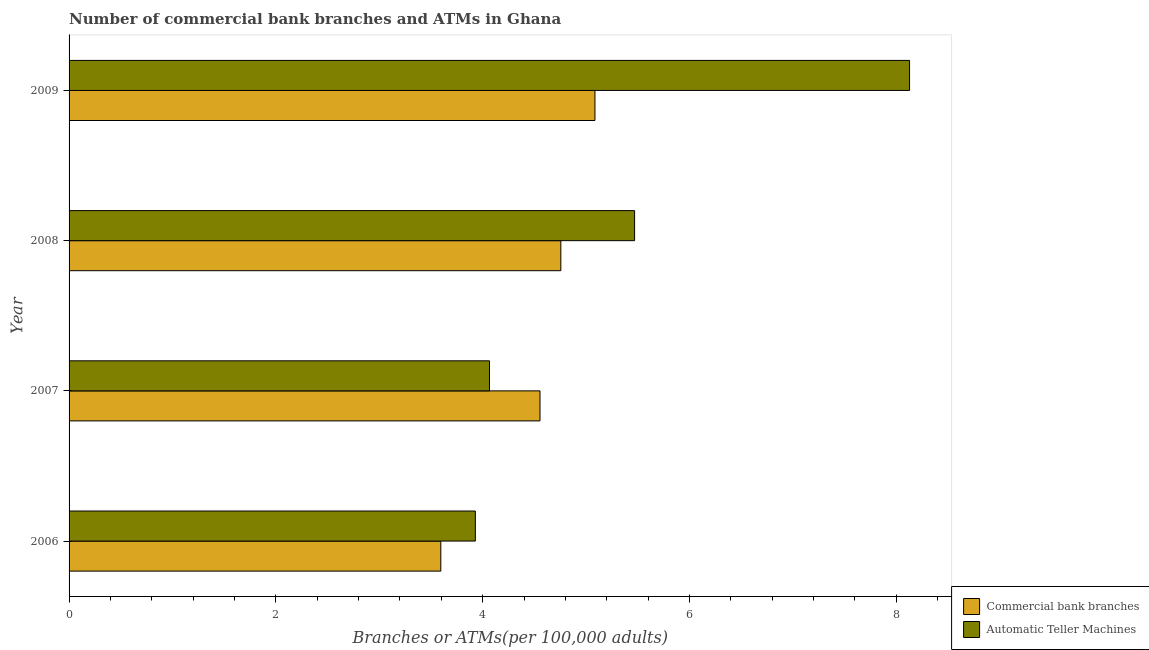How many different coloured bars are there?
Your answer should be very brief. 2. How many groups of bars are there?
Offer a very short reply. 4. Are the number of bars per tick equal to the number of legend labels?
Your answer should be very brief. Yes. Are the number of bars on each tick of the Y-axis equal?
Keep it short and to the point. Yes. What is the label of the 1st group of bars from the top?
Make the answer very short. 2009. What is the number of commercal bank branches in 2006?
Give a very brief answer. 3.6. Across all years, what is the maximum number of commercal bank branches?
Ensure brevity in your answer.  5.09. Across all years, what is the minimum number of atms?
Provide a succinct answer. 3.93. In which year was the number of atms minimum?
Make the answer very short. 2006. What is the total number of atms in the graph?
Provide a short and direct response. 21.59. What is the difference between the number of commercal bank branches in 2006 and that in 2008?
Provide a short and direct response. -1.16. What is the difference between the number of atms in 2006 and the number of commercal bank branches in 2008?
Your response must be concise. -0.83. What is the average number of commercal bank branches per year?
Keep it short and to the point. 4.5. In the year 2007, what is the difference between the number of commercal bank branches and number of atms?
Make the answer very short. 0.49. What is the ratio of the number of atms in 2006 to that in 2009?
Make the answer very short. 0.48. Is the number of atms in 2007 less than that in 2009?
Give a very brief answer. Yes. What is the difference between the highest and the second highest number of commercal bank branches?
Keep it short and to the point. 0.33. Is the sum of the number of commercal bank branches in 2007 and 2009 greater than the maximum number of atms across all years?
Keep it short and to the point. Yes. What does the 2nd bar from the top in 2008 represents?
Your answer should be compact. Commercial bank branches. What does the 2nd bar from the bottom in 2006 represents?
Your response must be concise. Automatic Teller Machines. How many years are there in the graph?
Provide a short and direct response. 4. Are the values on the major ticks of X-axis written in scientific E-notation?
Your response must be concise. No. Does the graph contain grids?
Keep it short and to the point. No. What is the title of the graph?
Give a very brief answer. Number of commercial bank branches and ATMs in Ghana. Does "Number of departures" appear as one of the legend labels in the graph?
Provide a short and direct response. No. What is the label or title of the X-axis?
Offer a very short reply. Branches or ATMs(per 100,0 adults). What is the label or title of the Y-axis?
Make the answer very short. Year. What is the Branches or ATMs(per 100,000 adults) of Commercial bank branches in 2006?
Your answer should be compact. 3.6. What is the Branches or ATMs(per 100,000 adults) of Automatic Teller Machines in 2006?
Keep it short and to the point. 3.93. What is the Branches or ATMs(per 100,000 adults) of Commercial bank branches in 2007?
Provide a succinct answer. 4.55. What is the Branches or ATMs(per 100,000 adults) of Automatic Teller Machines in 2007?
Ensure brevity in your answer.  4.07. What is the Branches or ATMs(per 100,000 adults) of Commercial bank branches in 2008?
Offer a terse response. 4.76. What is the Branches or ATMs(per 100,000 adults) in Automatic Teller Machines in 2008?
Give a very brief answer. 5.47. What is the Branches or ATMs(per 100,000 adults) of Commercial bank branches in 2009?
Provide a succinct answer. 5.09. What is the Branches or ATMs(per 100,000 adults) in Automatic Teller Machines in 2009?
Your answer should be very brief. 8.13. Across all years, what is the maximum Branches or ATMs(per 100,000 adults) in Commercial bank branches?
Make the answer very short. 5.09. Across all years, what is the maximum Branches or ATMs(per 100,000 adults) in Automatic Teller Machines?
Ensure brevity in your answer.  8.13. Across all years, what is the minimum Branches or ATMs(per 100,000 adults) of Commercial bank branches?
Your response must be concise. 3.6. Across all years, what is the minimum Branches or ATMs(per 100,000 adults) in Automatic Teller Machines?
Provide a short and direct response. 3.93. What is the total Branches or ATMs(per 100,000 adults) of Commercial bank branches in the graph?
Keep it short and to the point. 17.99. What is the total Branches or ATMs(per 100,000 adults) in Automatic Teller Machines in the graph?
Make the answer very short. 21.59. What is the difference between the Branches or ATMs(per 100,000 adults) of Commercial bank branches in 2006 and that in 2007?
Provide a short and direct response. -0.96. What is the difference between the Branches or ATMs(per 100,000 adults) of Automatic Teller Machines in 2006 and that in 2007?
Keep it short and to the point. -0.14. What is the difference between the Branches or ATMs(per 100,000 adults) of Commercial bank branches in 2006 and that in 2008?
Keep it short and to the point. -1.16. What is the difference between the Branches or ATMs(per 100,000 adults) in Automatic Teller Machines in 2006 and that in 2008?
Offer a terse response. -1.54. What is the difference between the Branches or ATMs(per 100,000 adults) of Commercial bank branches in 2006 and that in 2009?
Provide a succinct answer. -1.49. What is the difference between the Branches or ATMs(per 100,000 adults) in Automatic Teller Machines in 2006 and that in 2009?
Provide a short and direct response. -4.2. What is the difference between the Branches or ATMs(per 100,000 adults) of Commercial bank branches in 2007 and that in 2008?
Offer a terse response. -0.2. What is the difference between the Branches or ATMs(per 100,000 adults) of Automatic Teller Machines in 2007 and that in 2008?
Make the answer very short. -1.4. What is the difference between the Branches or ATMs(per 100,000 adults) of Commercial bank branches in 2007 and that in 2009?
Provide a succinct answer. -0.53. What is the difference between the Branches or ATMs(per 100,000 adults) of Automatic Teller Machines in 2007 and that in 2009?
Give a very brief answer. -4.06. What is the difference between the Branches or ATMs(per 100,000 adults) in Commercial bank branches in 2008 and that in 2009?
Offer a terse response. -0.33. What is the difference between the Branches or ATMs(per 100,000 adults) of Automatic Teller Machines in 2008 and that in 2009?
Keep it short and to the point. -2.66. What is the difference between the Branches or ATMs(per 100,000 adults) of Commercial bank branches in 2006 and the Branches or ATMs(per 100,000 adults) of Automatic Teller Machines in 2007?
Offer a terse response. -0.47. What is the difference between the Branches or ATMs(per 100,000 adults) of Commercial bank branches in 2006 and the Branches or ATMs(per 100,000 adults) of Automatic Teller Machines in 2008?
Your response must be concise. -1.87. What is the difference between the Branches or ATMs(per 100,000 adults) of Commercial bank branches in 2006 and the Branches or ATMs(per 100,000 adults) of Automatic Teller Machines in 2009?
Make the answer very short. -4.53. What is the difference between the Branches or ATMs(per 100,000 adults) in Commercial bank branches in 2007 and the Branches or ATMs(per 100,000 adults) in Automatic Teller Machines in 2008?
Make the answer very short. -0.91. What is the difference between the Branches or ATMs(per 100,000 adults) in Commercial bank branches in 2007 and the Branches or ATMs(per 100,000 adults) in Automatic Teller Machines in 2009?
Keep it short and to the point. -3.57. What is the difference between the Branches or ATMs(per 100,000 adults) of Commercial bank branches in 2008 and the Branches or ATMs(per 100,000 adults) of Automatic Teller Machines in 2009?
Your response must be concise. -3.37. What is the average Branches or ATMs(per 100,000 adults) of Commercial bank branches per year?
Offer a very short reply. 4.5. What is the average Branches or ATMs(per 100,000 adults) of Automatic Teller Machines per year?
Offer a very short reply. 5.4. In the year 2006, what is the difference between the Branches or ATMs(per 100,000 adults) of Commercial bank branches and Branches or ATMs(per 100,000 adults) of Automatic Teller Machines?
Ensure brevity in your answer.  -0.33. In the year 2007, what is the difference between the Branches or ATMs(per 100,000 adults) of Commercial bank branches and Branches or ATMs(per 100,000 adults) of Automatic Teller Machines?
Your answer should be compact. 0.49. In the year 2008, what is the difference between the Branches or ATMs(per 100,000 adults) of Commercial bank branches and Branches or ATMs(per 100,000 adults) of Automatic Teller Machines?
Provide a short and direct response. -0.71. In the year 2009, what is the difference between the Branches or ATMs(per 100,000 adults) in Commercial bank branches and Branches or ATMs(per 100,000 adults) in Automatic Teller Machines?
Your answer should be compact. -3.04. What is the ratio of the Branches or ATMs(per 100,000 adults) of Commercial bank branches in 2006 to that in 2007?
Make the answer very short. 0.79. What is the ratio of the Branches or ATMs(per 100,000 adults) of Automatic Teller Machines in 2006 to that in 2007?
Offer a terse response. 0.97. What is the ratio of the Branches or ATMs(per 100,000 adults) in Commercial bank branches in 2006 to that in 2008?
Give a very brief answer. 0.76. What is the ratio of the Branches or ATMs(per 100,000 adults) of Automatic Teller Machines in 2006 to that in 2008?
Keep it short and to the point. 0.72. What is the ratio of the Branches or ATMs(per 100,000 adults) in Commercial bank branches in 2006 to that in 2009?
Ensure brevity in your answer.  0.71. What is the ratio of the Branches or ATMs(per 100,000 adults) of Automatic Teller Machines in 2006 to that in 2009?
Offer a terse response. 0.48. What is the ratio of the Branches or ATMs(per 100,000 adults) of Commercial bank branches in 2007 to that in 2008?
Ensure brevity in your answer.  0.96. What is the ratio of the Branches or ATMs(per 100,000 adults) of Automatic Teller Machines in 2007 to that in 2008?
Offer a very short reply. 0.74. What is the ratio of the Branches or ATMs(per 100,000 adults) of Commercial bank branches in 2007 to that in 2009?
Offer a very short reply. 0.9. What is the ratio of the Branches or ATMs(per 100,000 adults) of Automatic Teller Machines in 2007 to that in 2009?
Give a very brief answer. 0.5. What is the ratio of the Branches or ATMs(per 100,000 adults) of Commercial bank branches in 2008 to that in 2009?
Provide a succinct answer. 0.94. What is the ratio of the Branches or ATMs(per 100,000 adults) in Automatic Teller Machines in 2008 to that in 2009?
Make the answer very short. 0.67. What is the difference between the highest and the second highest Branches or ATMs(per 100,000 adults) in Commercial bank branches?
Provide a succinct answer. 0.33. What is the difference between the highest and the second highest Branches or ATMs(per 100,000 adults) in Automatic Teller Machines?
Give a very brief answer. 2.66. What is the difference between the highest and the lowest Branches or ATMs(per 100,000 adults) in Commercial bank branches?
Make the answer very short. 1.49. What is the difference between the highest and the lowest Branches or ATMs(per 100,000 adults) of Automatic Teller Machines?
Your response must be concise. 4.2. 